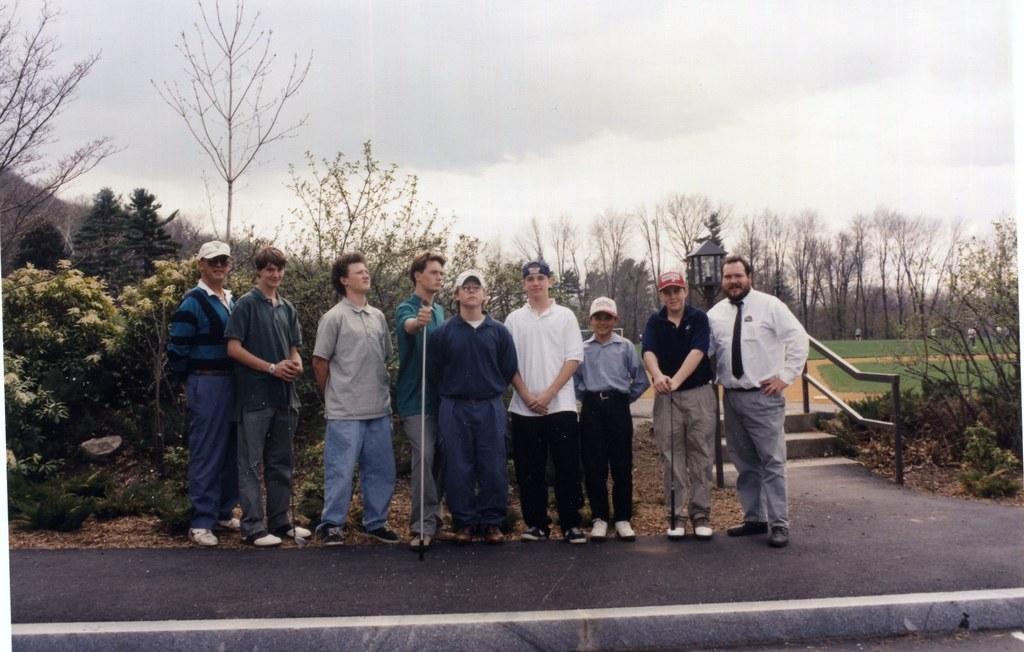Please provide a concise description of this image. This picture is taken beside the road. Beside the road, there are group of people standing in a row. In the center, there is a man holding a stick. Towards the right corner, there is a man wearing white shirt, grey trousers and a black tie. Towards the left corner, there is another man wearing a blue t shirt, blue jeans and a white cap. In the background, there are trees, grass and sky. 